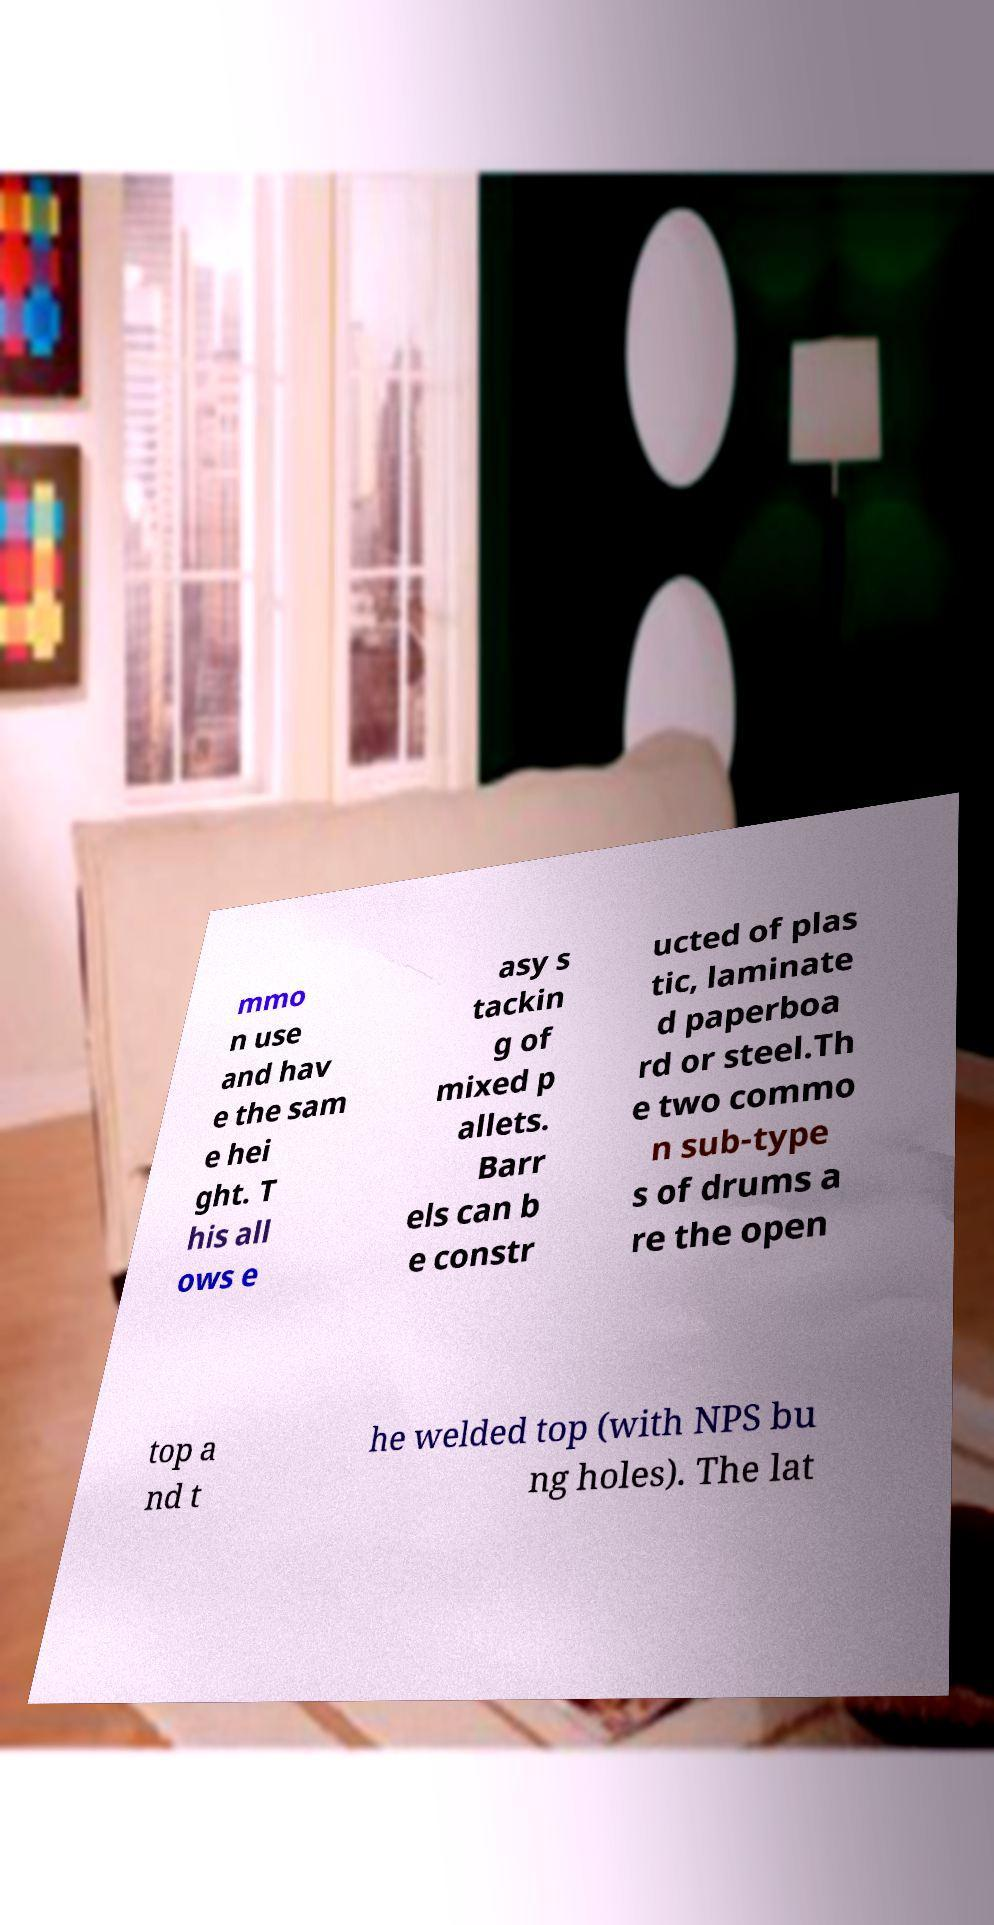Can you read and provide the text displayed in the image?This photo seems to have some interesting text. Can you extract and type it out for me? mmo n use and hav e the sam e hei ght. T his all ows e asy s tackin g of mixed p allets. Barr els can b e constr ucted of plas tic, laminate d paperboa rd or steel.Th e two commo n sub-type s of drums a re the open top a nd t he welded top (with NPS bu ng holes). The lat 